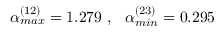Convert formula to latex. <formula><loc_0><loc_0><loc_500><loc_500>\alpha _ { \max } ^ { ( 1 2 ) } = 1 . 2 7 9 \ , \quad a l p h a _ { \min } ^ { ( 2 3 ) } = 0 . 2 9 5</formula> 